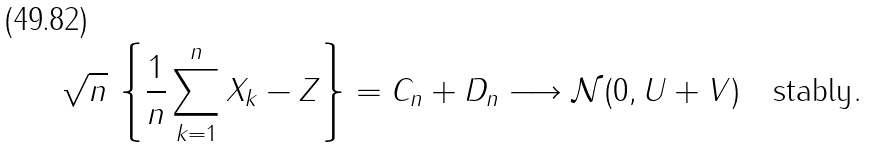<formula> <loc_0><loc_0><loc_500><loc_500>\sqrt { n } \, \left \{ \frac { 1 } { n } \sum _ { k = 1 } ^ { n } X _ { k } - Z \right \} = C _ { n } + D _ { n } \longrightarrow \mathcal { N } ( 0 , U + V ) \quad \text {stably} .</formula> 